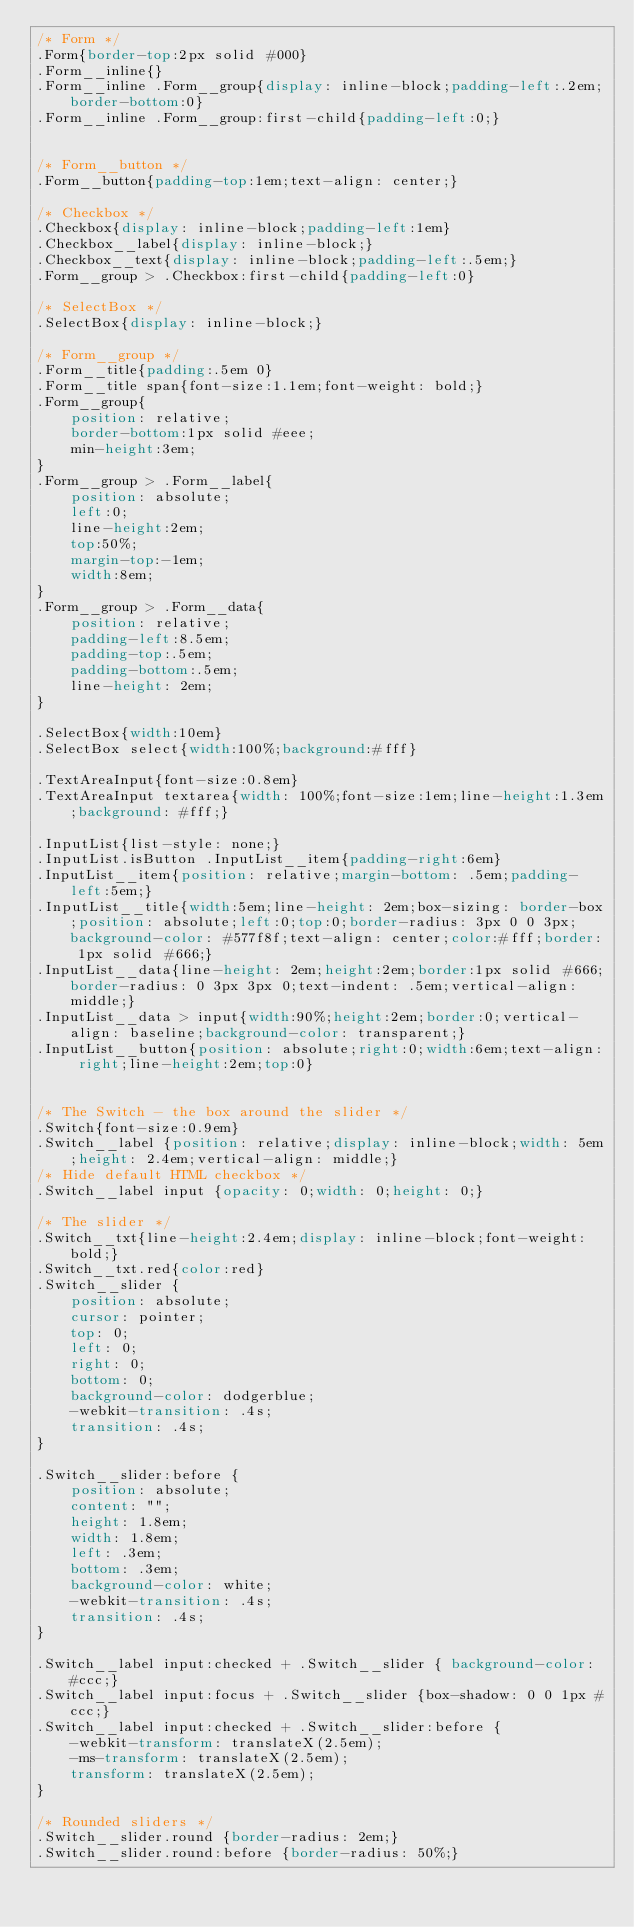Convert code to text. <code><loc_0><loc_0><loc_500><loc_500><_CSS_>/* Form */
.Form{border-top:2px solid #000}
.Form__inline{}
.Form__inline .Form__group{display: inline-block;padding-left:.2em;border-bottom:0}
.Form__inline .Form__group:first-child{padding-left:0;}


/* Form__button */
.Form__button{padding-top:1em;text-align: center;}

/* Checkbox */
.Checkbox{display: inline-block;padding-left:1em}
.Checkbox__label{display: inline-block;}
.Checkbox__text{display: inline-block;padding-left:.5em;}
.Form__group > .Checkbox:first-child{padding-left:0}

/* SelectBox */
.SelectBox{display: inline-block;}

/* Form__group */
.Form__title{padding:.5em 0}
.Form__title span{font-size:1.1em;font-weight: bold;}
.Form__group{
    position: relative;
    border-bottom:1px solid #eee;
    min-height:3em;
}
.Form__group > .Form__label{
    position: absolute;
    left:0;
    line-height:2em;
    top:50%;
    margin-top:-1em;
    width:8em;
}
.Form__group > .Form__data{
    position: relative;
    padding-left:8.5em;
    padding-top:.5em;
    padding-bottom:.5em;
    line-height: 2em;
}

.SelectBox{width:10em}
.SelectBox select{width:100%;background:#fff}

.TextAreaInput{font-size:0.8em}
.TextAreaInput textarea{width: 100%;font-size:1em;line-height:1.3em;background: #fff;}

.InputList{list-style: none;}
.InputList.isButton .InputList__item{padding-right:6em}
.InputList__item{position: relative;margin-bottom: .5em;padding-left:5em;}
.InputList__title{width:5em;line-height: 2em;box-sizing: border-box;position: absolute;left:0;top:0;border-radius: 3px 0 0 3px;background-color: #577f8f;text-align: center;color:#fff;border: 1px solid #666;}
.InputList__data{line-height: 2em;height:2em;border:1px solid #666;border-radius: 0 3px 3px 0;text-indent: .5em;vertical-align: middle;}
.InputList__data > input{width:90%;height:2em;border:0;vertical-align: baseline;background-color: transparent;}
.InputList__button{position: absolute;right:0;width:6em;text-align: right;line-height:2em;top:0}


/* The Switch - the box around the slider */
.Switch{font-size:0.9em}
.Switch__label {position: relative;display: inline-block;width: 5em;height: 2.4em;vertical-align: middle;}
/* Hide default HTML checkbox */
.Switch__label input {opacity: 0;width: 0;height: 0;}
  
/* The slider */
.Switch__txt{line-height:2.4em;display: inline-block;font-weight: bold;}
.Switch__txt.red{color:red}
.Switch__slider {
    position: absolute;
    cursor: pointer;
    top: 0;
    left: 0;
    right: 0;
    bottom: 0;
    background-color: dodgerblue;
    -webkit-transition: .4s;
    transition: .4s;
}

.Switch__slider:before {
    position: absolute;
    content: "";
    height: 1.8em;
    width: 1.8em;
    left: .3em;
    bottom: .3em;
    background-color: white;
    -webkit-transition: .4s;
    transition: .4s;
}

.Switch__label input:checked + .Switch__slider { background-color: #ccc;}
.Switch__label input:focus + .Switch__slider {box-shadow: 0 0 1px #ccc;}
.Switch__label input:checked + .Switch__slider:before {
    -webkit-transform: translateX(2.5em);
    -ms-transform: translateX(2.5em);
    transform: translateX(2.5em);
}

/* Rounded sliders */
.Switch__slider.round {border-radius: 2em;}
.Switch__slider.round:before {border-radius: 50%;}</code> 